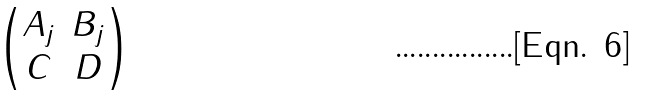<formula> <loc_0><loc_0><loc_500><loc_500>\begin{pmatrix} A _ { j } & B _ { j } \\ C & D \end{pmatrix}</formula> 